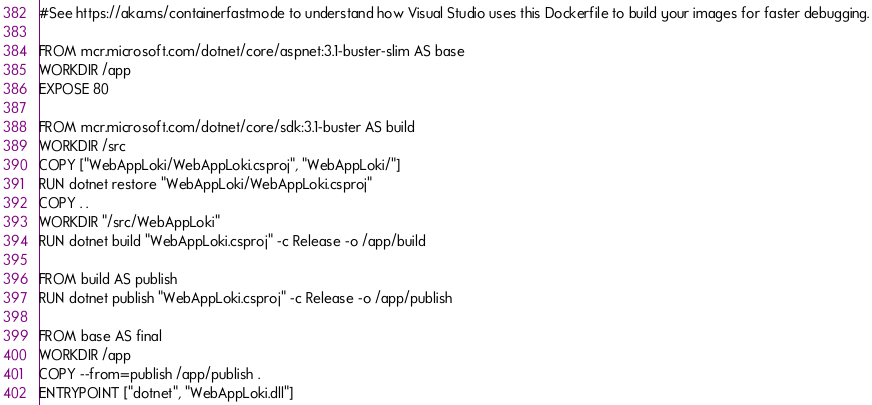Convert code to text. <code><loc_0><loc_0><loc_500><loc_500><_Dockerfile_>#See https://aka.ms/containerfastmode to understand how Visual Studio uses this Dockerfile to build your images for faster debugging.

FROM mcr.microsoft.com/dotnet/core/aspnet:3.1-buster-slim AS base
WORKDIR /app
EXPOSE 80

FROM mcr.microsoft.com/dotnet/core/sdk:3.1-buster AS build
WORKDIR /src
COPY ["WebAppLoki/WebAppLoki.csproj", "WebAppLoki/"]
RUN dotnet restore "WebAppLoki/WebAppLoki.csproj"
COPY . .
WORKDIR "/src/WebAppLoki"
RUN dotnet build "WebAppLoki.csproj" -c Release -o /app/build

FROM build AS publish
RUN dotnet publish "WebAppLoki.csproj" -c Release -o /app/publish

FROM base AS final
WORKDIR /app
COPY --from=publish /app/publish .
ENTRYPOINT ["dotnet", "WebAppLoki.dll"]</code> 